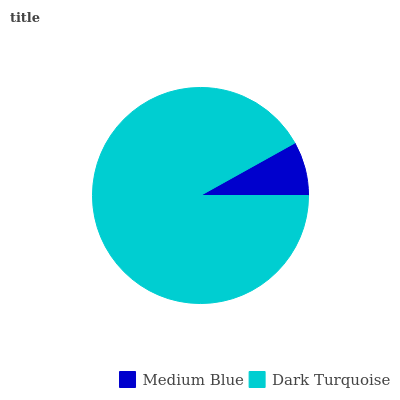Is Medium Blue the minimum?
Answer yes or no. Yes. Is Dark Turquoise the maximum?
Answer yes or no. Yes. Is Dark Turquoise the minimum?
Answer yes or no. No. Is Dark Turquoise greater than Medium Blue?
Answer yes or no. Yes. Is Medium Blue less than Dark Turquoise?
Answer yes or no. Yes. Is Medium Blue greater than Dark Turquoise?
Answer yes or no. No. Is Dark Turquoise less than Medium Blue?
Answer yes or no. No. Is Dark Turquoise the high median?
Answer yes or no. Yes. Is Medium Blue the low median?
Answer yes or no. Yes. Is Medium Blue the high median?
Answer yes or no. No. Is Dark Turquoise the low median?
Answer yes or no. No. 